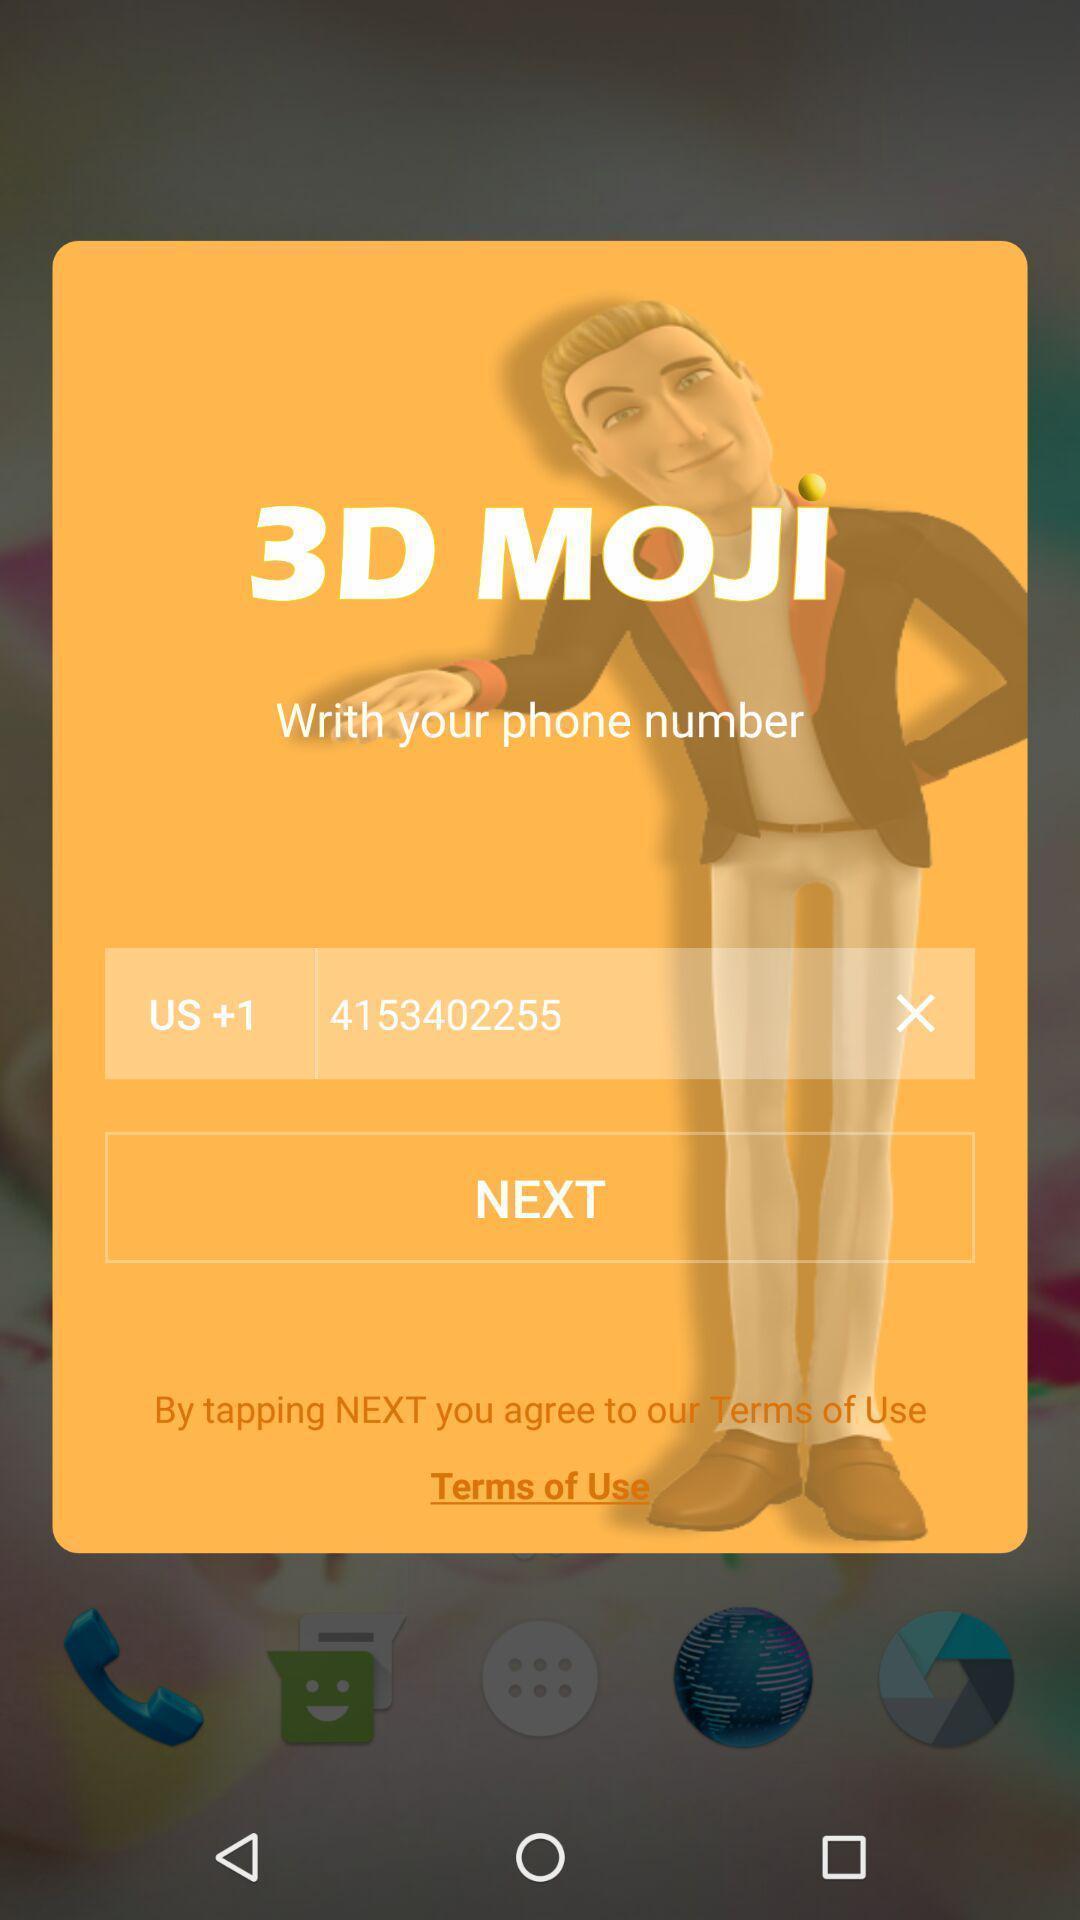Describe the content in this image. Pop up showing to add phone number. 